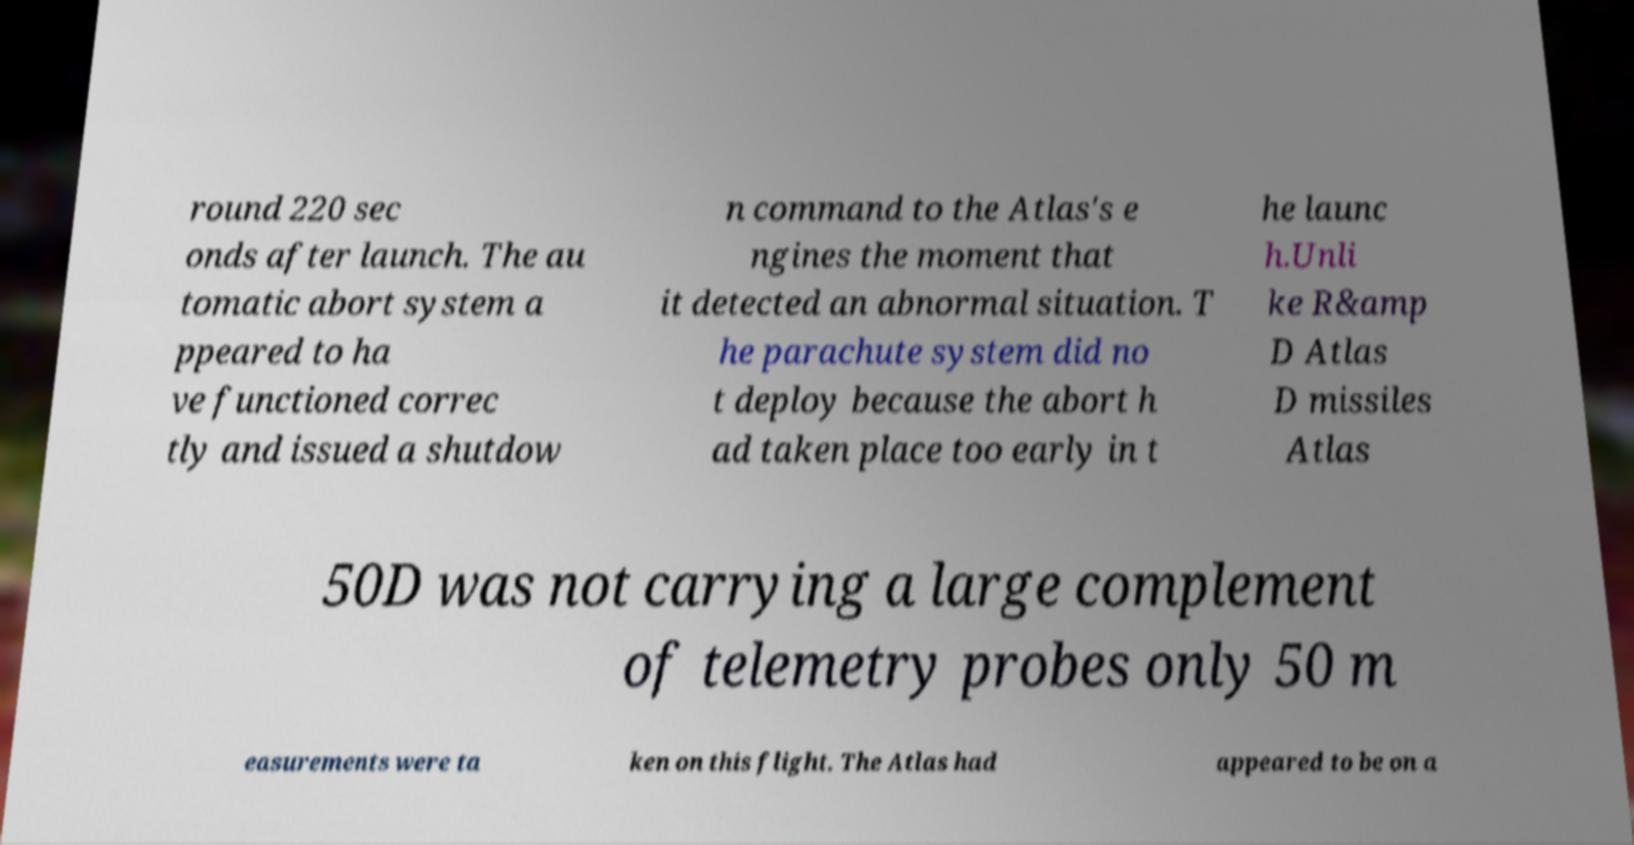For documentation purposes, I need the text within this image transcribed. Could you provide that? round 220 sec onds after launch. The au tomatic abort system a ppeared to ha ve functioned correc tly and issued a shutdow n command to the Atlas's e ngines the moment that it detected an abnormal situation. T he parachute system did no t deploy because the abort h ad taken place too early in t he launc h.Unli ke R&amp D Atlas D missiles Atlas 50D was not carrying a large complement of telemetry probes only 50 m easurements were ta ken on this flight. The Atlas had appeared to be on a 